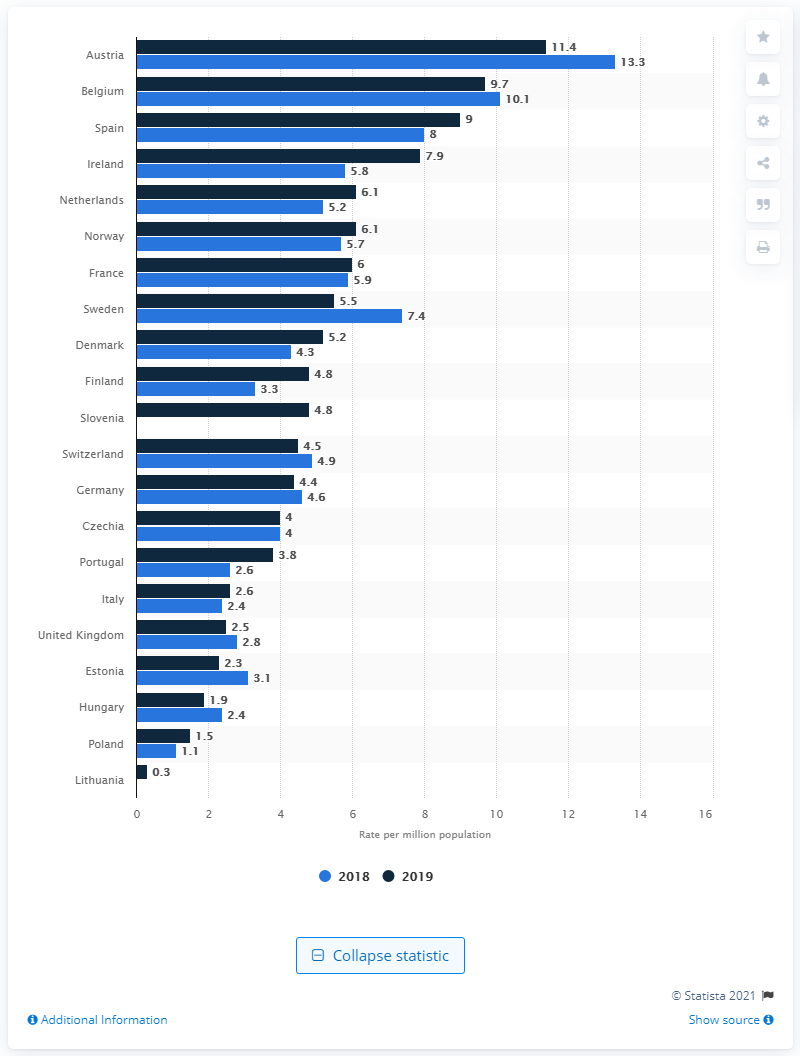Outline some significant characteristics in this image. In 2019, Austria had the highest rate of lung transplants among all countries. According to data from 2019, Belgium had the second highest rate of lung transplants among all countries. The country with the largest rate increase between the years was Ireland. 